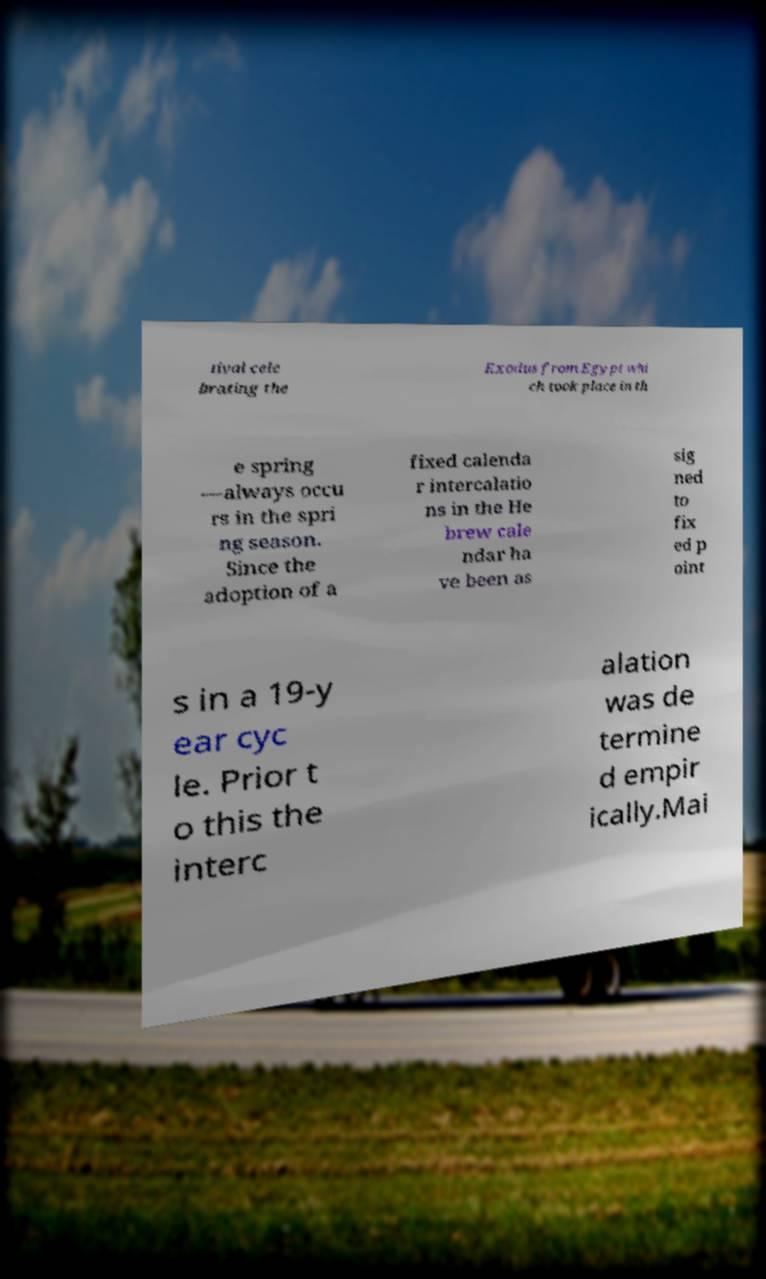Could you extract and type out the text from this image? tival cele brating the Exodus from Egypt whi ch took place in th e spring —always occu rs in the spri ng season. Since the adoption of a fixed calenda r intercalatio ns in the He brew cale ndar ha ve been as sig ned to fix ed p oint s in a 19-y ear cyc le. Prior t o this the interc alation was de termine d empir ically.Mai 